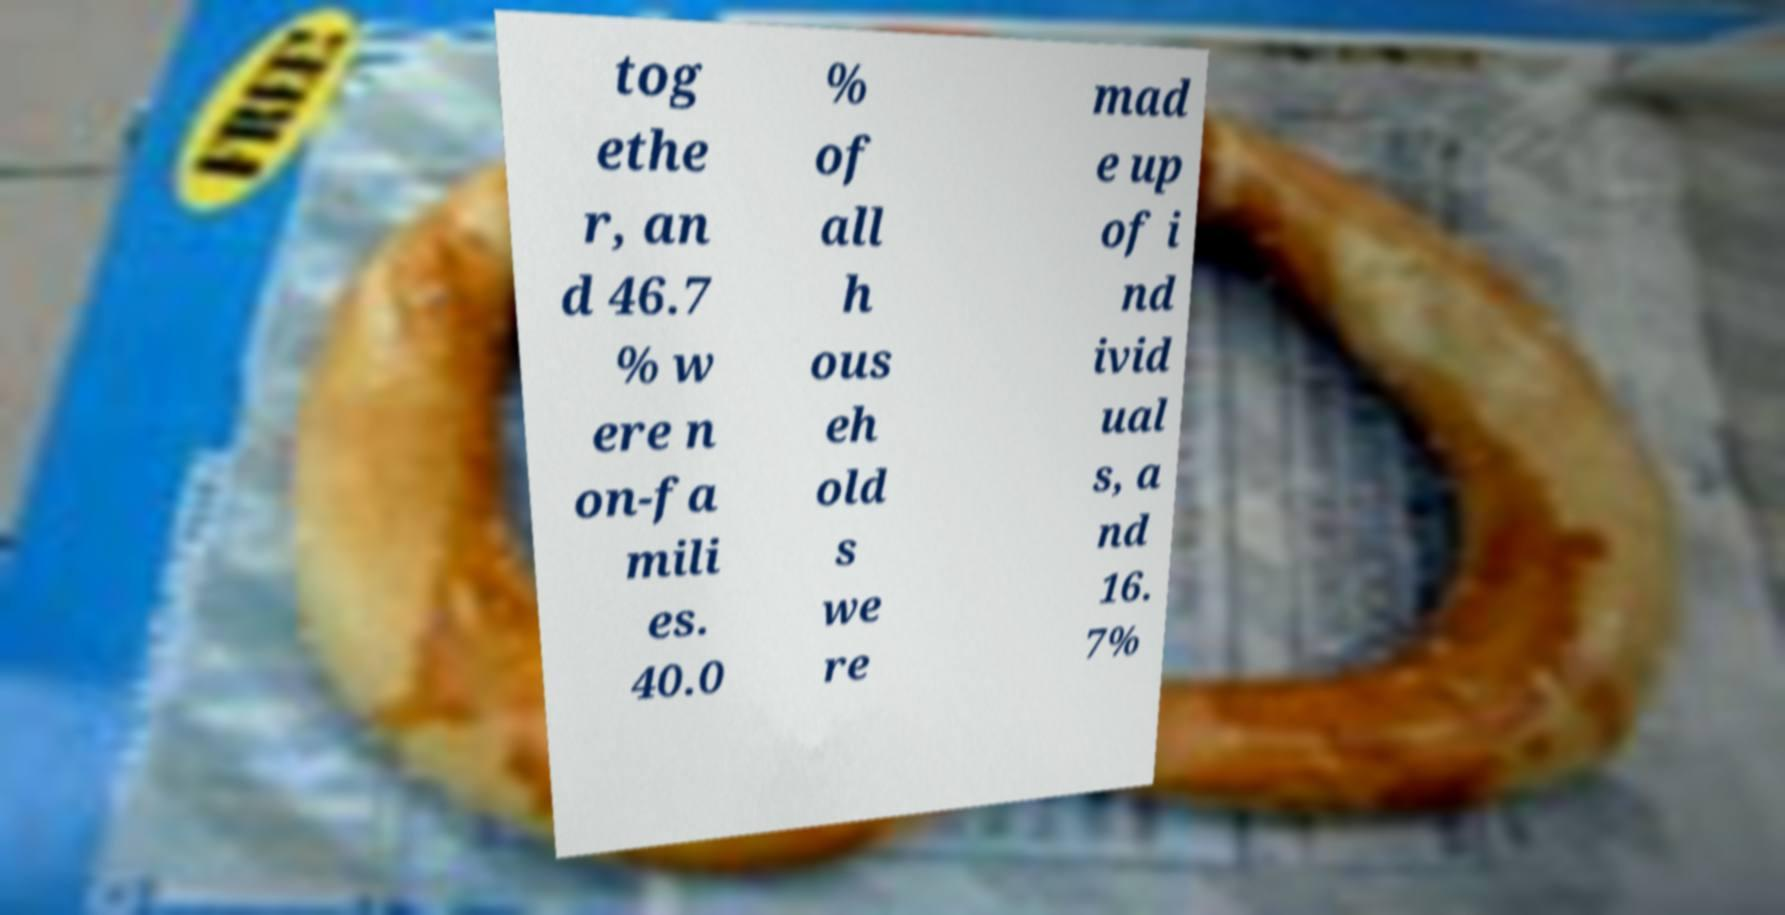Could you assist in decoding the text presented in this image and type it out clearly? tog ethe r, an d 46.7 % w ere n on-fa mili es. 40.0 % of all h ous eh old s we re mad e up of i nd ivid ual s, a nd 16. 7% 